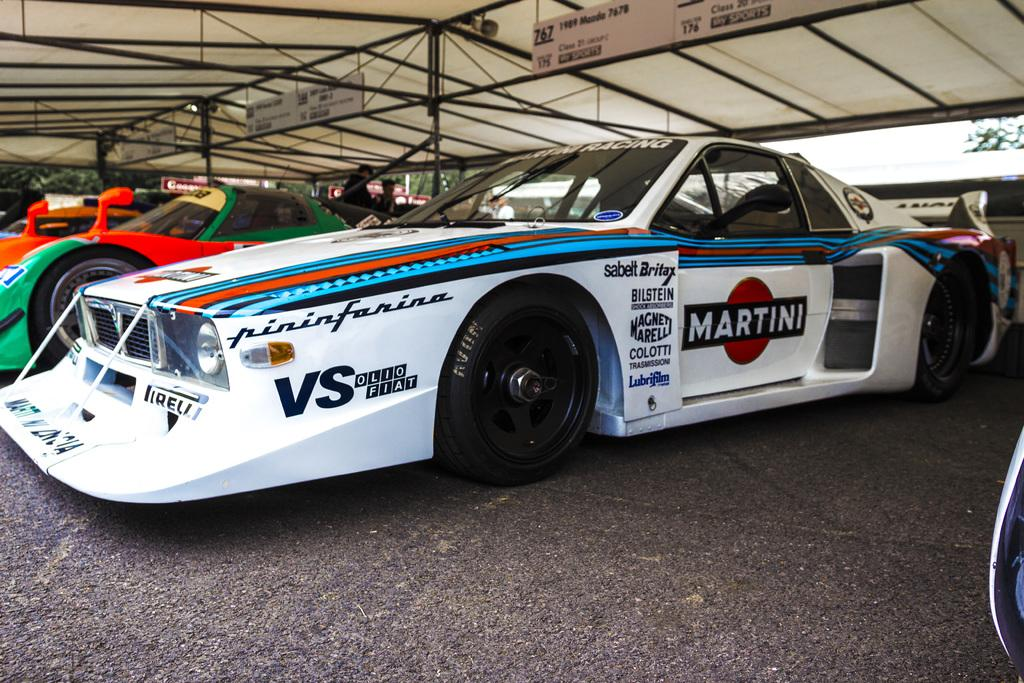What is happening in the image? There are people standing in the image. What structure can be seen in the image? There is a tent in the image. What objects are attached to a rod in the image? There are boards attached to a rod in the image. What type of transportation is visible in the image? There are vehicles on the road in the image. What is visible in the background of the image? The sky is visible in the image. Can you see any dinosaurs roaming around in the image? No, there are no dinosaurs present in the image. What type of straw is being used by the people in the image? There is no straw visible in the image. 